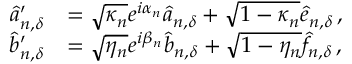Convert formula to latex. <formula><loc_0><loc_0><loc_500><loc_500>\begin{array} { r l } { \hat { a } _ { n , { \delta } } ^ { \prime } } & { = \sqrt { \kappa _ { n } } e ^ { i \alpha _ { n } } \hat { a } _ { n , { \delta } } + \sqrt { 1 - \kappa _ { n } } \hat { e } _ { n , { \delta } } \, , } \\ { \hat { b } _ { n , { \delta } } ^ { \prime } } & { = \sqrt { \eta _ { n } } e ^ { i \beta _ { n } } \hat { b } _ { n , { \delta } } + \sqrt { 1 - \eta _ { n } } \hat { f } _ { n , { \delta } } \, , } \end{array}</formula> 